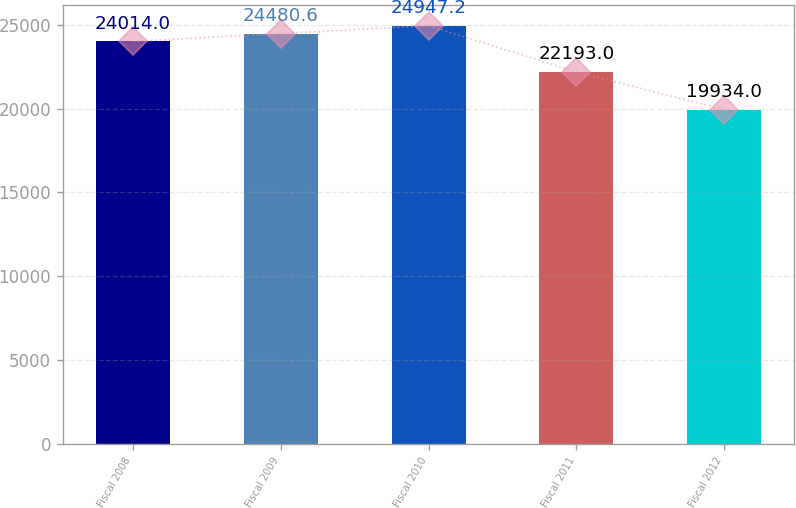Convert chart to OTSL. <chart><loc_0><loc_0><loc_500><loc_500><bar_chart><fcel>Fiscal 2008<fcel>Fiscal 2009<fcel>Fiscal 2010<fcel>Fiscal 2011<fcel>Fiscal 2012<nl><fcel>24014<fcel>24480.6<fcel>24947.2<fcel>22193<fcel>19934<nl></chart> 